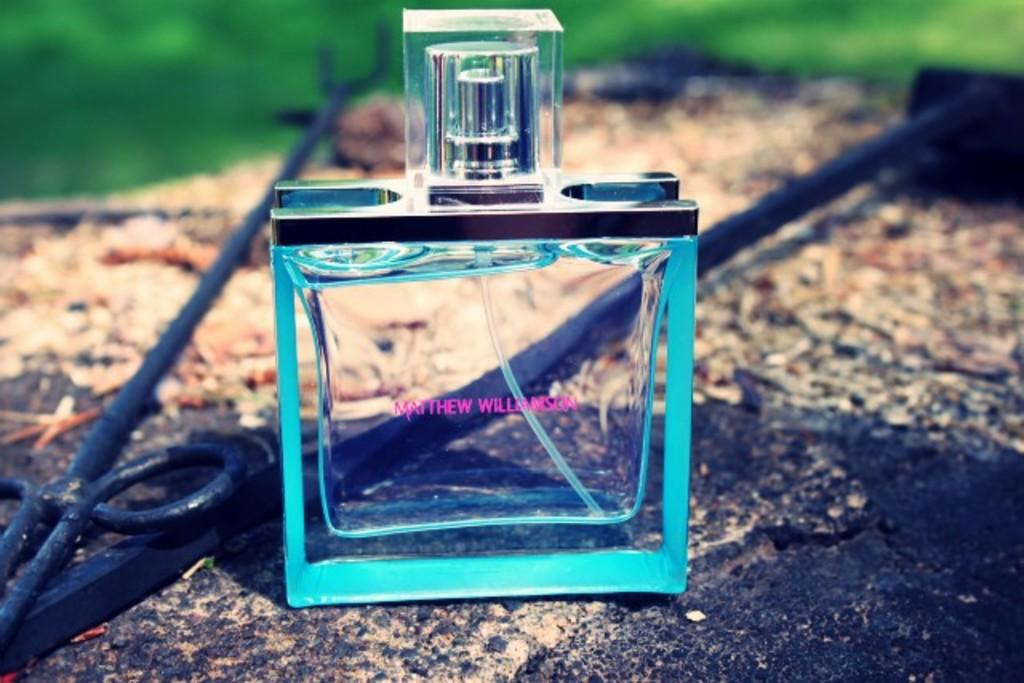What is the name of the perfume?
Provide a succinct answer. Matthew williamson. 